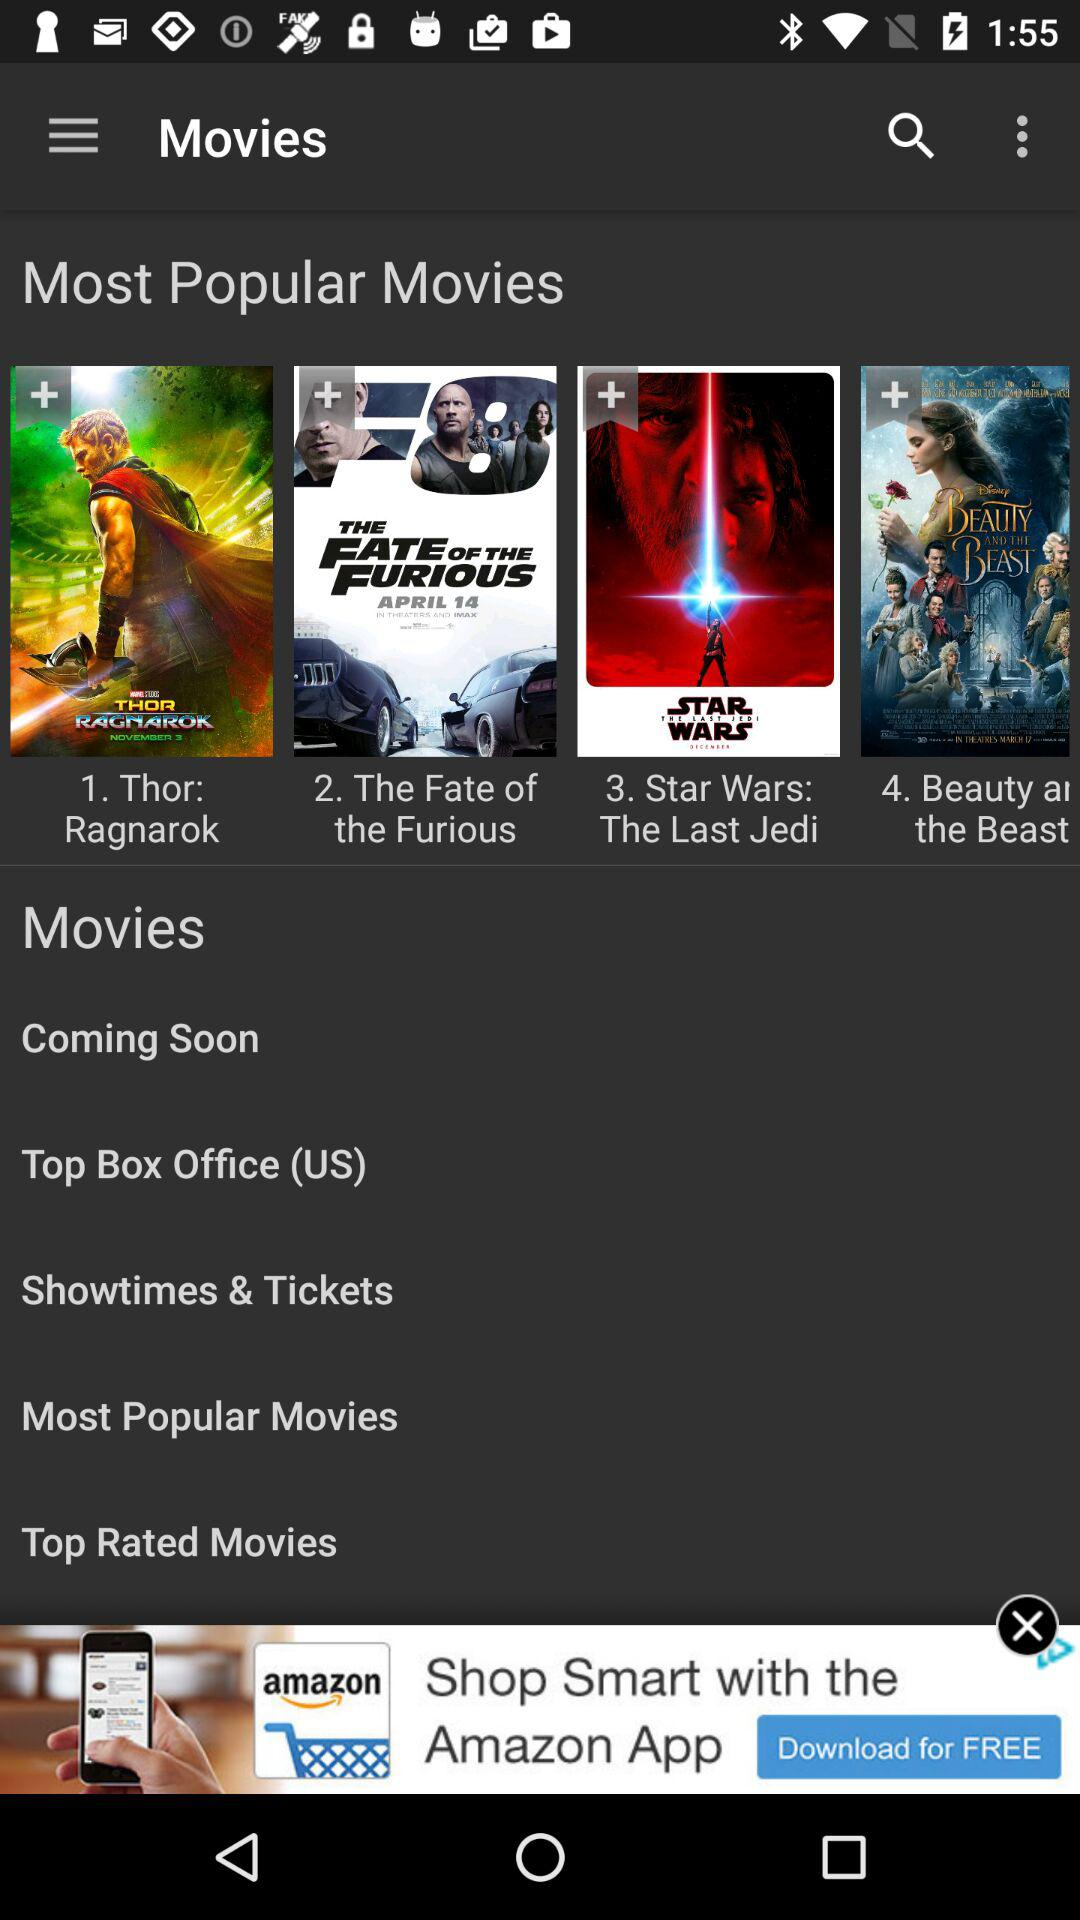What are the most popular movies? The most popular movies are "Thor: Ragnarok", "The Fate of the Furious" and "Star Wars: The Last Jedi". 